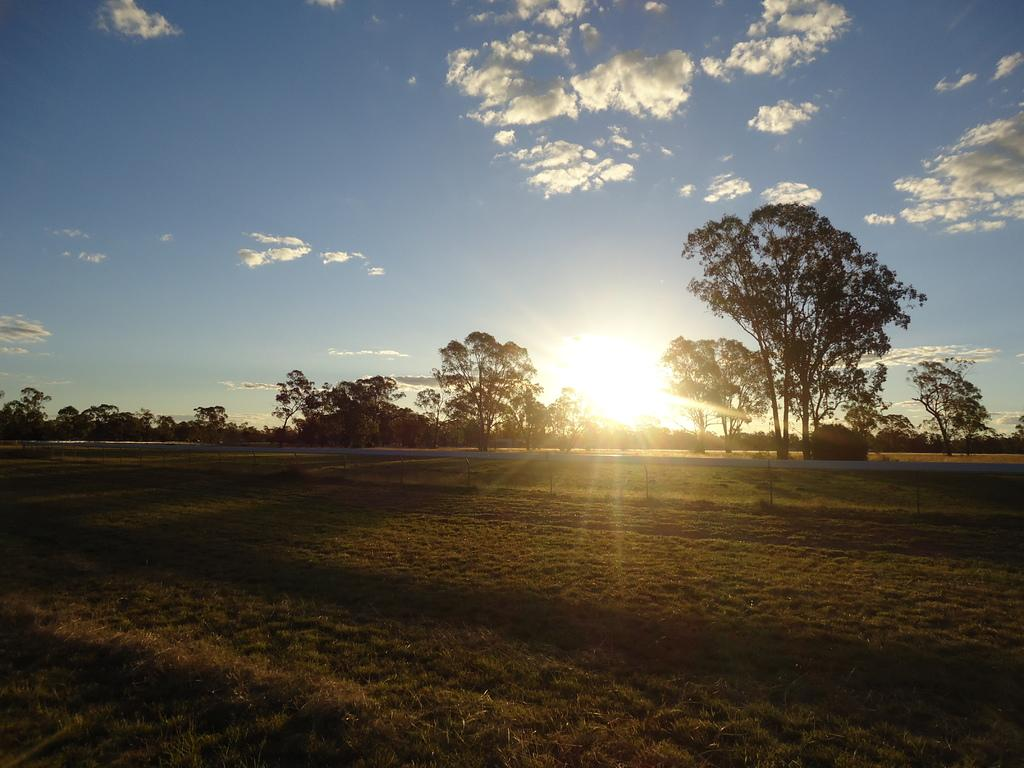What type of vegetation can be seen in the image? There is grass in the image. What else can be seen in the image besides grass? There are many trees in the image. What is visible in the background of the image? The sun, clouds, and a blue sky are visible in the background of the image. What type of map is being used for lunch in the image? There is no map or lunch present in the image; it features grass, trees, and a background with the sun, clouds, and a blue sky. 